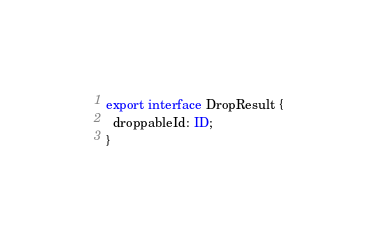Convert code to text. <code><loc_0><loc_0><loc_500><loc_500><_TypeScript_>
export interface DropResult {
  droppableId: ID;
}
</code> 